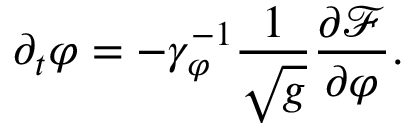Convert formula to latex. <formula><loc_0><loc_0><loc_500><loc_500>\partial _ { t } \varphi = - \gamma _ { \varphi } ^ { - 1 } \frac { 1 } { \sqrt { g } } { \frac { \partial \mathcal { F } } { \partial \varphi } } .</formula> 